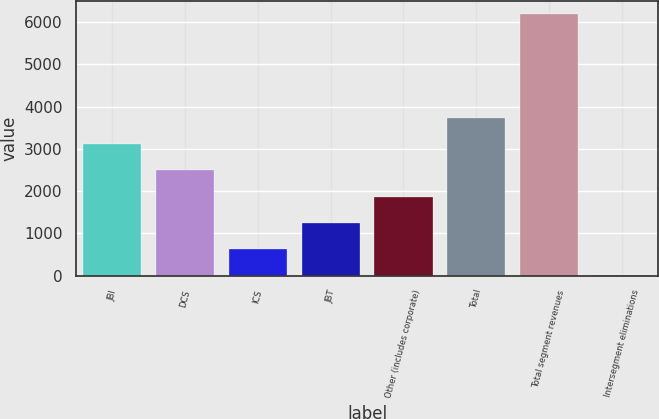Convert chart. <chart><loc_0><loc_0><loc_500><loc_500><bar_chart><fcel>JBI<fcel>DCS<fcel>ICS<fcel>JBT<fcel>Other (includes corporate)<fcel>Total<fcel>Total segment revenues<fcel>Intersegment eliminations<nl><fcel>3107<fcel>2488.2<fcel>631.8<fcel>1250.6<fcel>1869.4<fcel>3725.8<fcel>6201<fcel>13<nl></chart> 